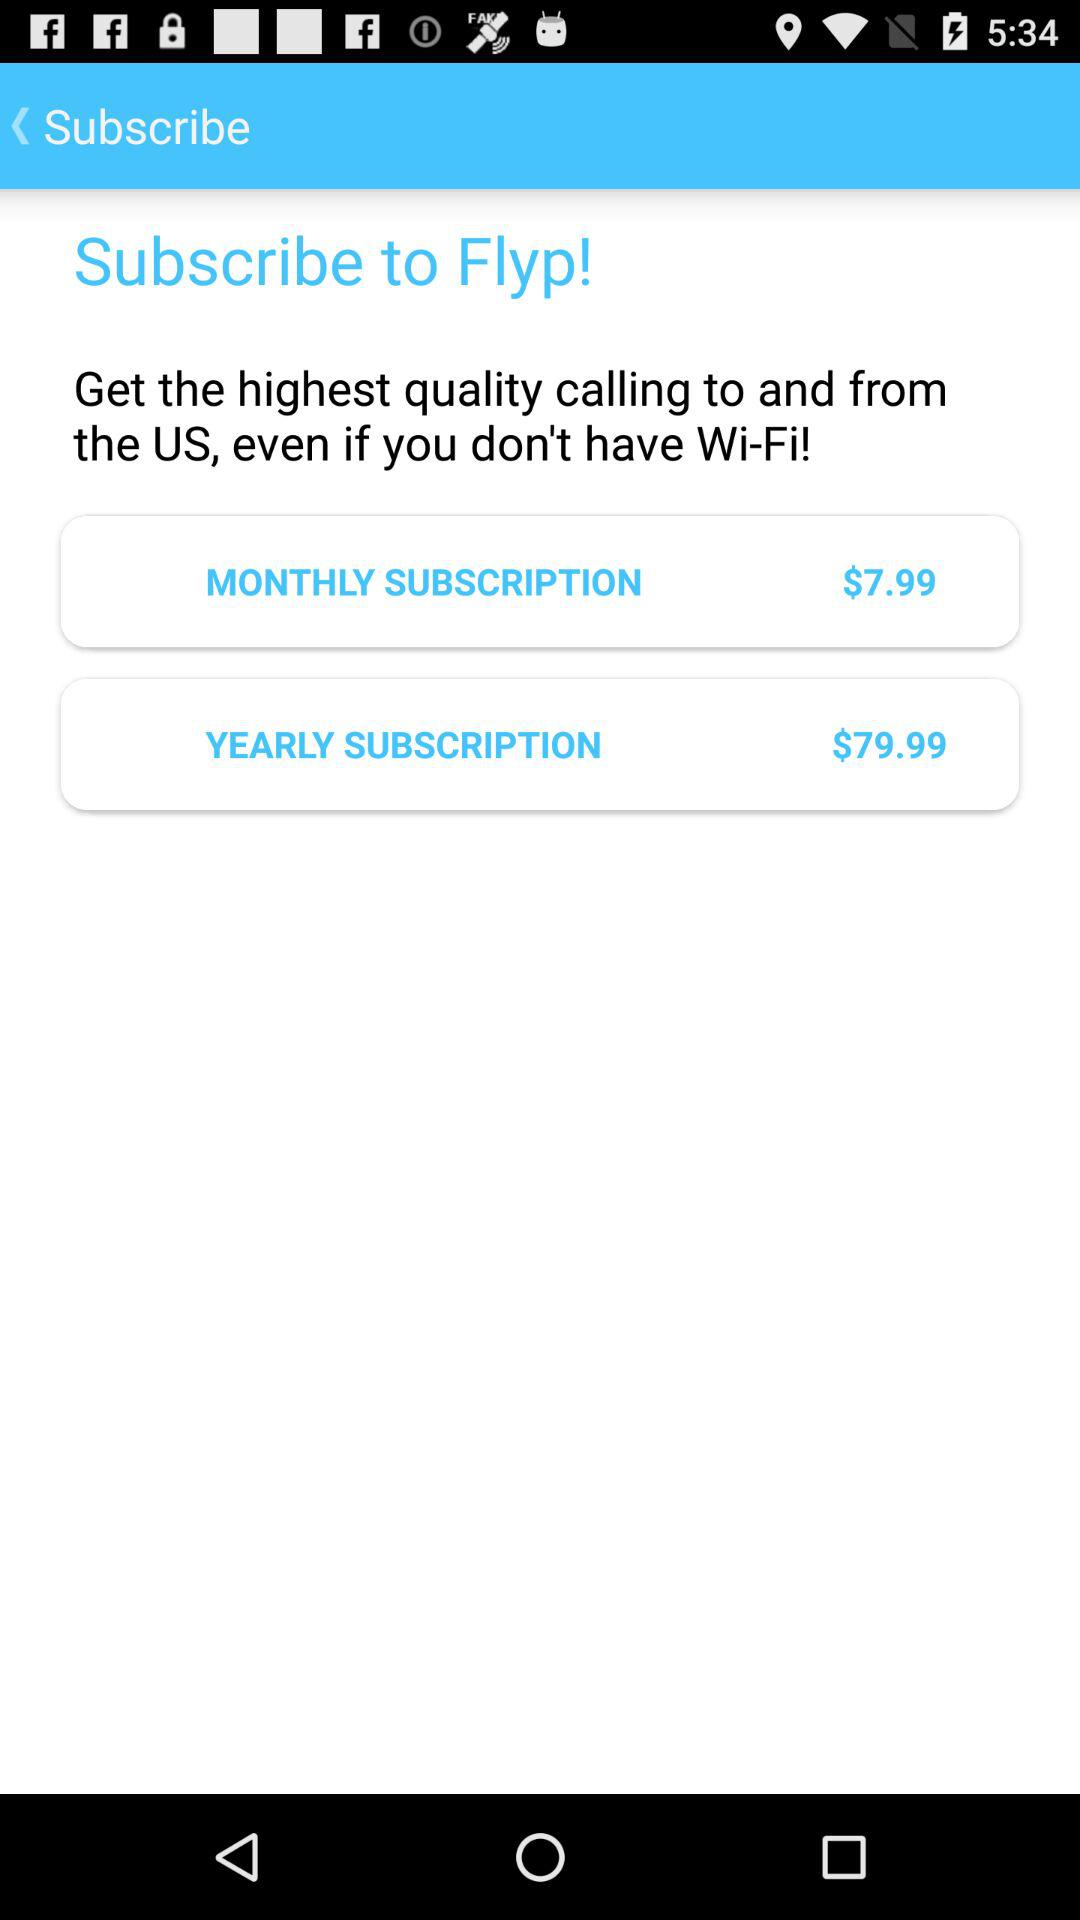What is the price of the yearly subscription? The price of the yearly subscription is $79.99. 